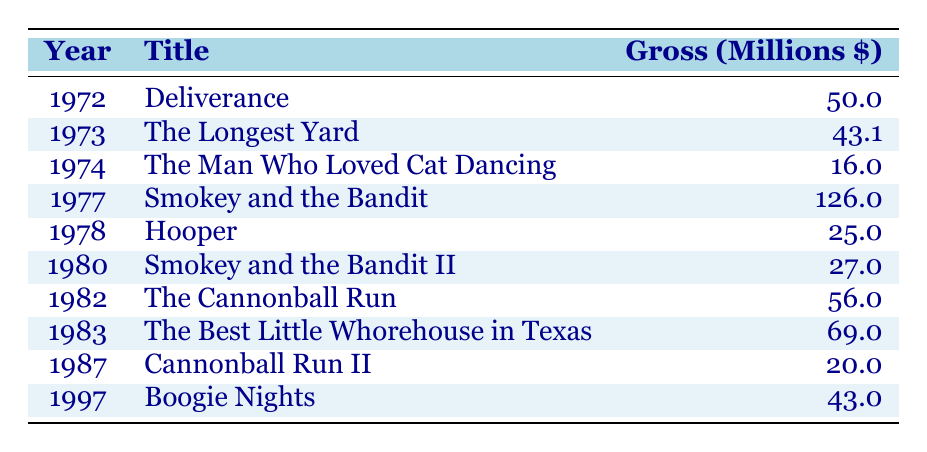What was the highest grossing film of Burt Reynolds? The table indicates the gross earnings for all listed films, and 'Smokey and the Bandit' in 1977 has the highest amount of 126 million dollars.
Answer: 126 million In which year was 'The Longest Yard' released? By looking at the table, 'The Longest Yard' is shown to be released in 1973.
Answer: 1973 How much did 'Hooper' gross? The gross earnings for 'Hooper' are listed in the table as 25 million dollars.
Answer: 25 million What is the average gross for Burt Reynolds films released before 1980? The films released before 1980 are 'Deliverance' (50.0), 'The Longest Yard' (43.1), 'The Man Who Loved Cat Dancing' (16.0), 'Smokey and the Bandit' (126.0), and 'Hooper' (25.0). Adding these gives a total gross of 260.1 million dollars, and there are 5 films, so the average gross is 260.1/5 = 52.02 million dollars.
Answer: 52.02 million Did any Burt Reynolds film gross over 100 million dollars? The data shows that 'Smokey and the Bandit' grossed 126 million dollars, confirming that yes, at least one film did exceed that amount.
Answer: Yes Which film had the lowest grossing amount? The analysis of the gross figures shows 'The Man Who Loved Cat Dancing' with 16 million, making it the lowest grossing film of those listed.
Answer: 16 million How many films grossed over 40 million dollars? The films that grossed over 40 million dollars are 'Deliverance' (50.0), 'The Longest Yard' (43.1), 'Smokey and the Bandit' (126.0), 'The Cannonball Run' (56.0), and 'The Best Little Whorehouse in Texas' (69.0). Thus, the total count of these films is 5.
Answer: 5 What year did Burt Reynolds’ films start to gross over 50 million dollars? The first film to gross over 50 million dollars, as per the table, is 'Deliverance' in 1972, but it did not cross 50 million. The next applicable film is 'Smokey and the Bandit' which grossed 126 million in 1977. Hence, 1977 is the first year he had films earning over 50 million.
Answer: 1977 